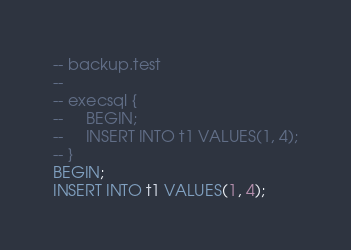Convert code to text. <code><loc_0><loc_0><loc_500><loc_500><_SQL_>-- backup.test
-- 
-- execsql { 
--     BEGIN;
--     INSERT INTO t1 VALUES(1, 4);
-- }
BEGIN;
INSERT INTO t1 VALUES(1, 4);</code> 